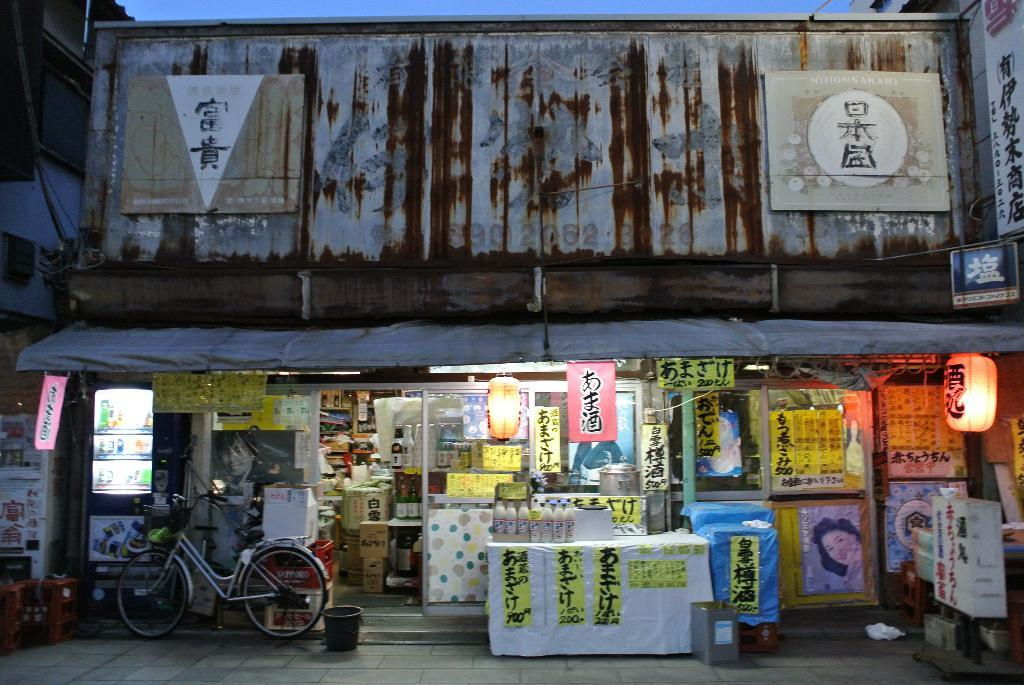<image>
Provide a brief description of the given image. A storefront with a table in front with signs with the numbers 900 and 200 on them. 